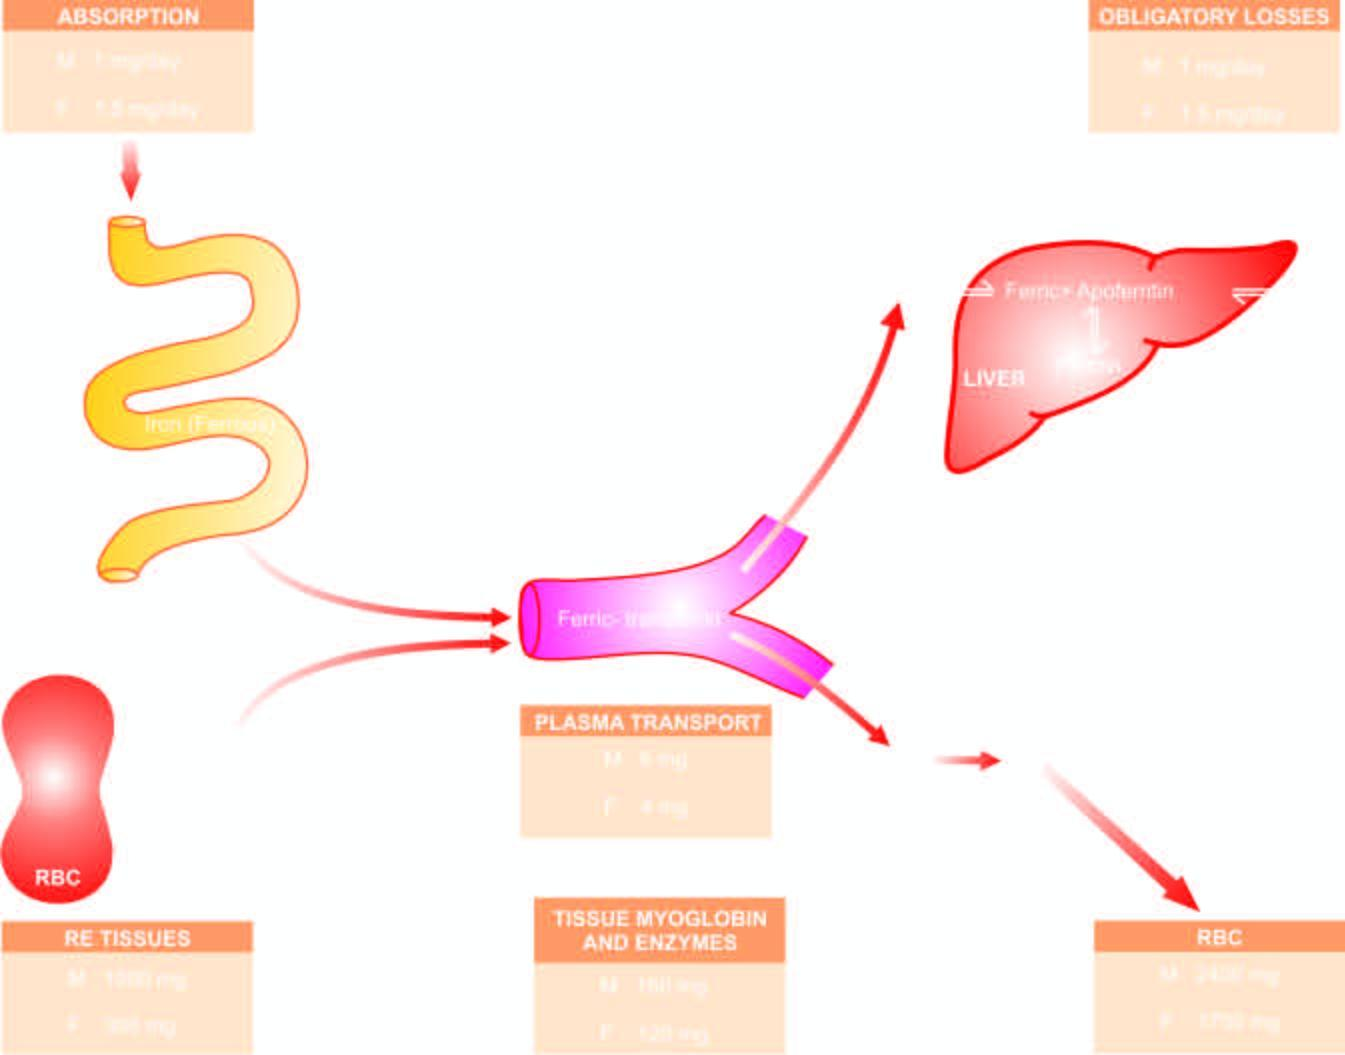what is stored iron mobilised in response to?
Answer the question using a single word or phrase. Increased demand and used for haemoglobin synthesis 